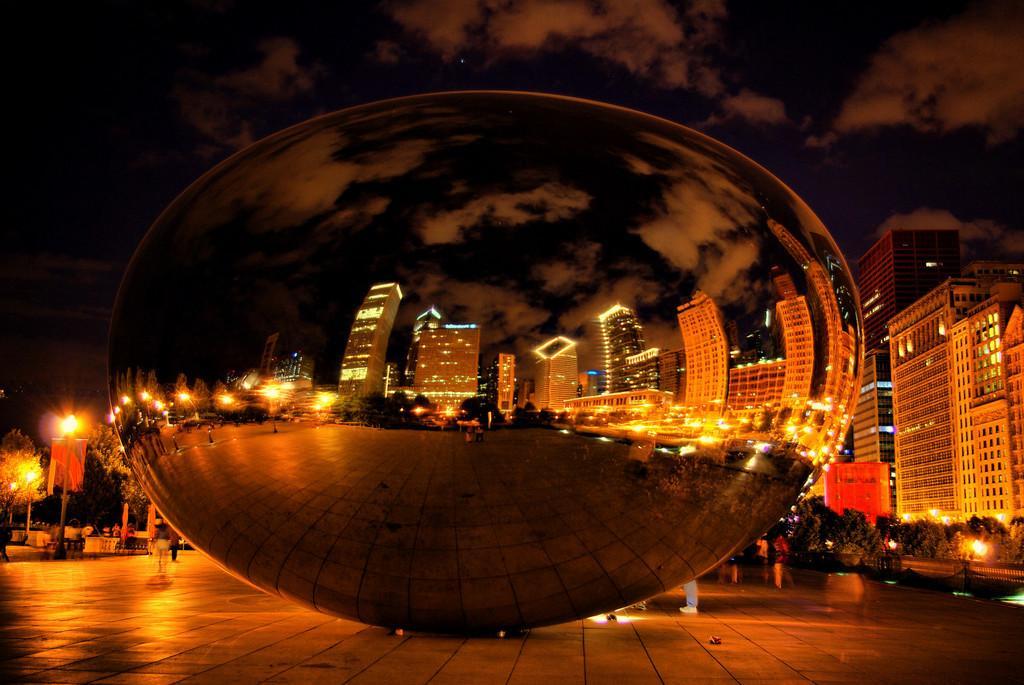Could you give a brief overview of what you see in this image? This picture is clicked outside. In the center there is an object seems to be the sculpture, on the surface of the object we can see the reflection of the sky and the reflection of buildings, lights and some other objects. In the background we can see the trees, group of persons, sky, lights and buildings and we can see the sky with some clouds. 